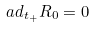Convert formula to latex. <formula><loc_0><loc_0><loc_500><loc_500>a d _ { t _ { + } } R _ { 0 } = 0</formula> 